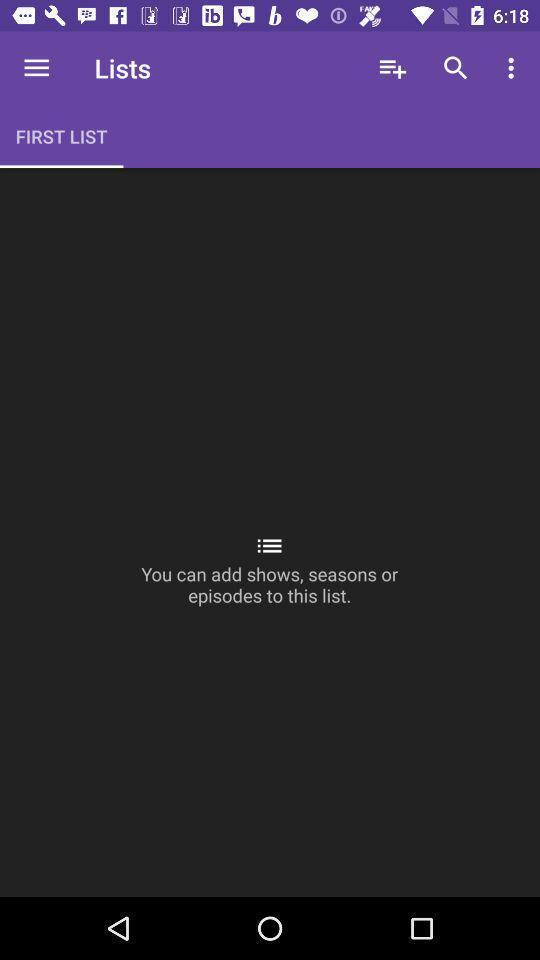What can you discern from this picture? Page showing you can add shows in the list. 